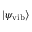<formula> <loc_0><loc_0><loc_500><loc_500>| \psi _ { v i b } \rangle</formula> 